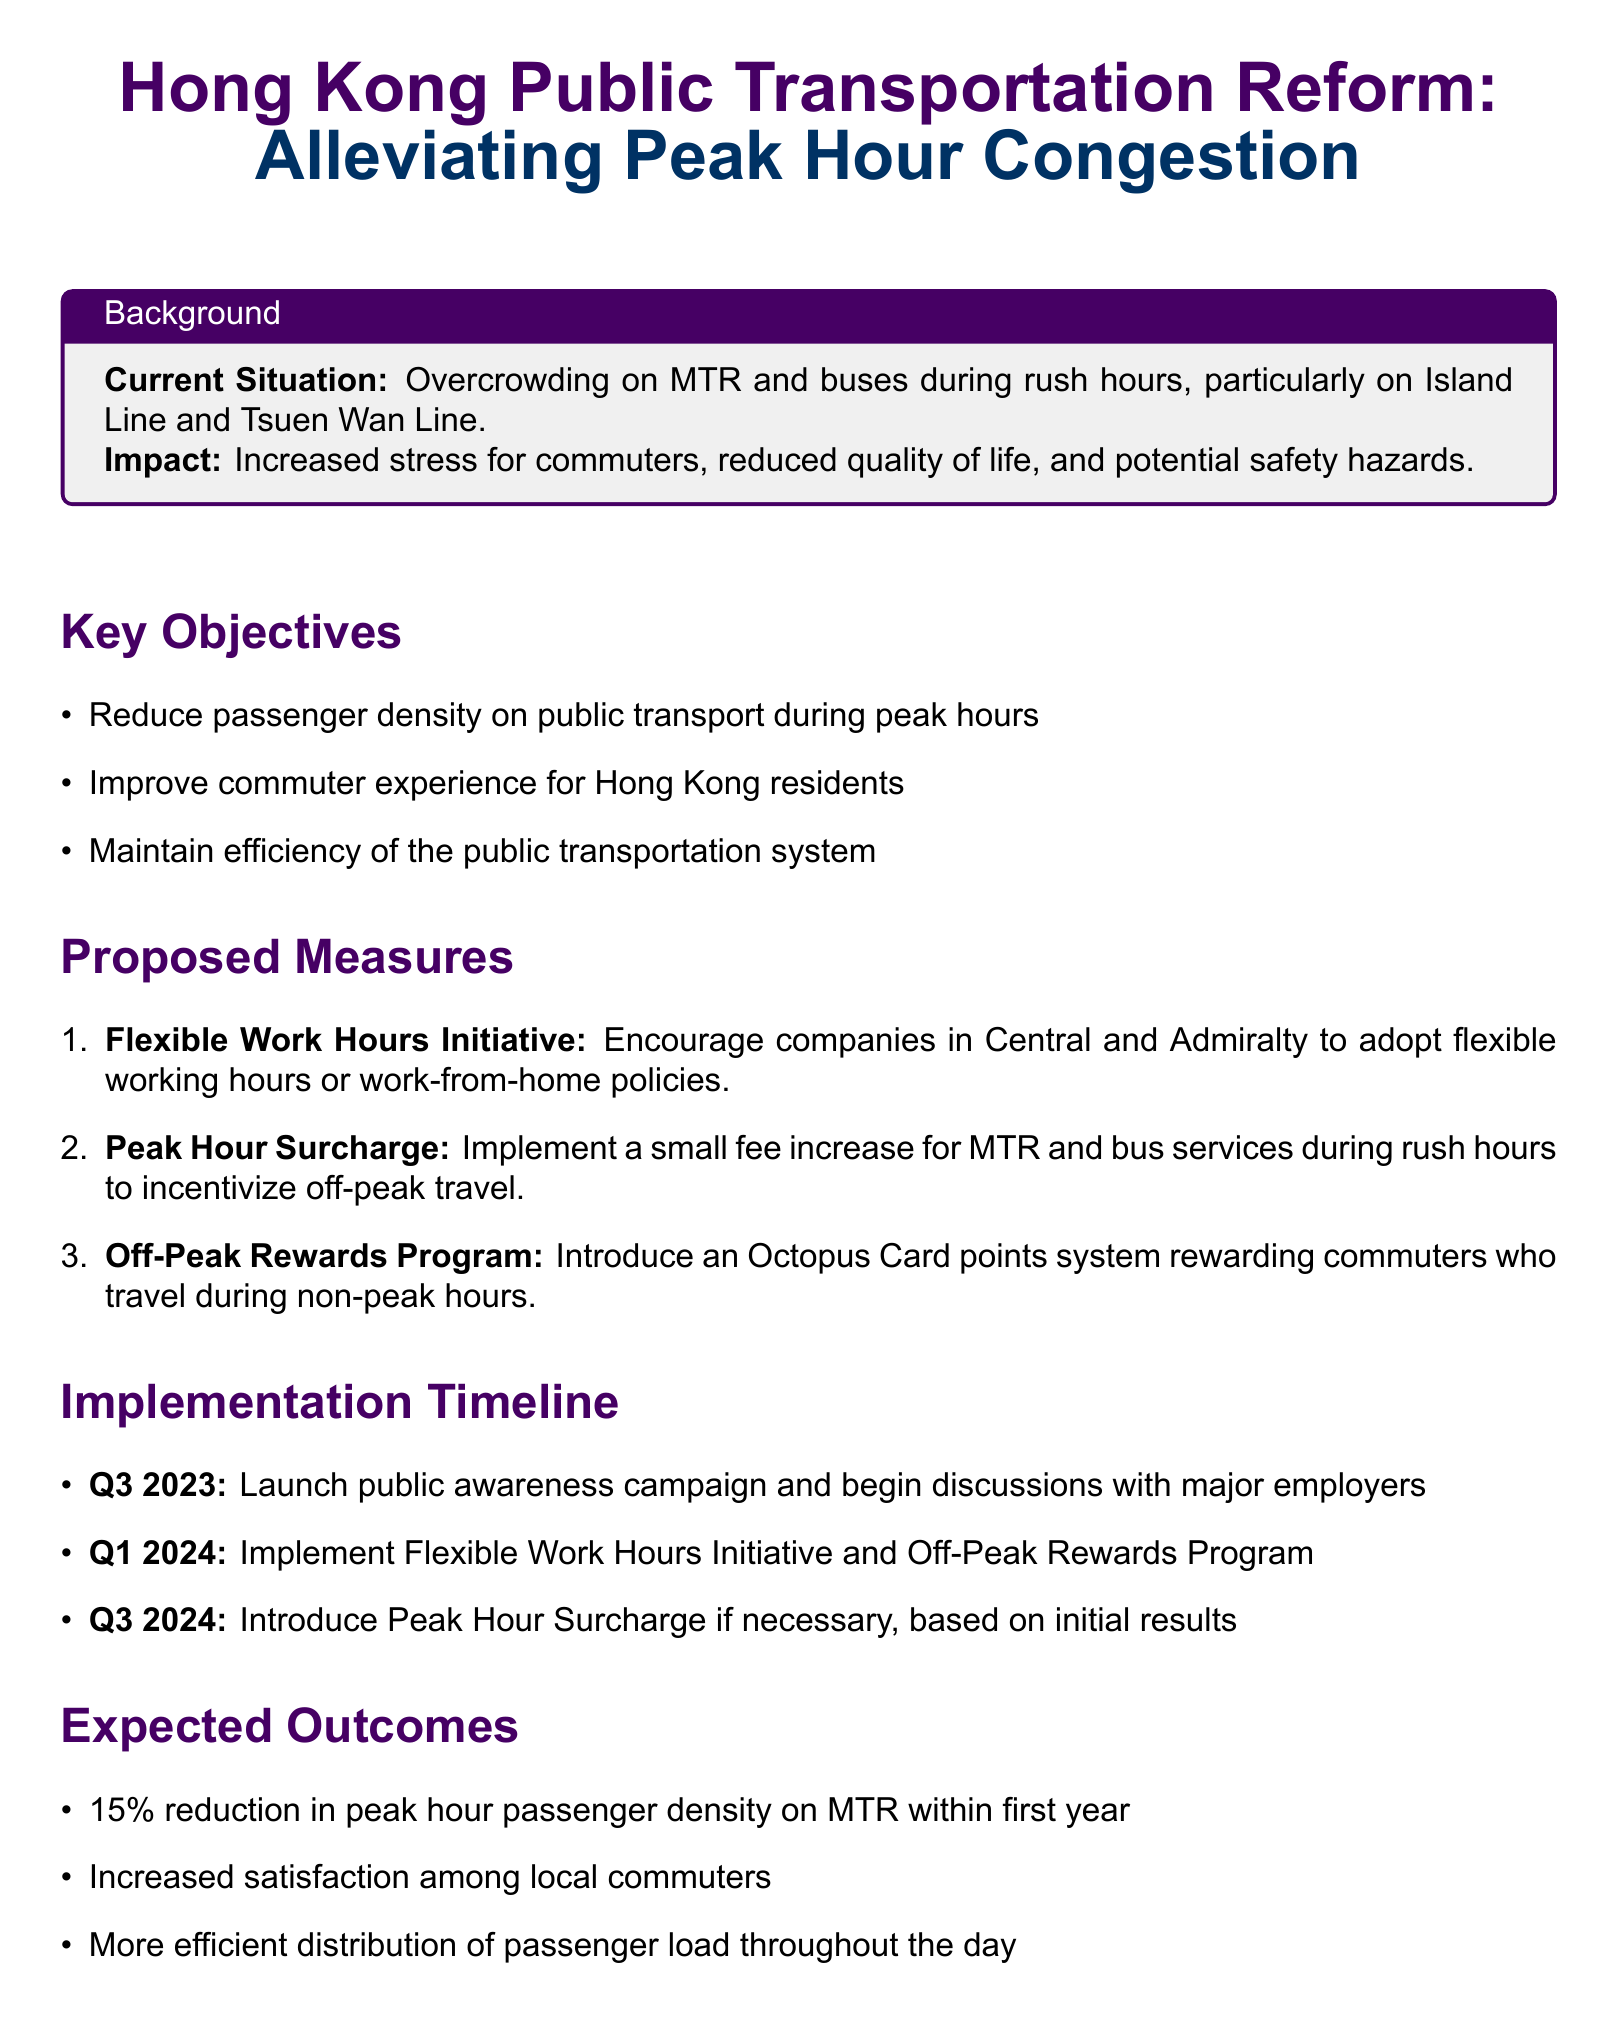What is the main goal of the public transportation reform? The main goal is to alleviate peak hour congestion in Hong Kong's public transport system, as stated in the document title.
Answer: Alleviating peak hour congestion What percentage reduction in peak hour passenger density is expected? The document mentions an expected outcome of a 15% reduction in peak hour passenger density on MTR within the first year.
Answer: 15% What initiative is proposed to encourage off-peak travel? The document lists an "Off-Peak Rewards Program" as a proposed measure to incentivize commuters to travel during non-peak hours.
Answer: Off-Peak Rewards Program When will the Flexible Work Hours Initiative be implemented? The timeline specifies that the Flexible Work Hours Initiative will be implemented in Q1 2024.
Answer: Q1 2024 What is the method for monitoring the initiative's outcomes? The monitoring and evaluation section states that quarterly surveys will be conducted by the Transport Department.
Answer: Quarterly surveys What are the expected results regarding commuter satisfaction? The expected outcome mentioned is increased satisfaction among local commuters due to the proposed measures.
Answer: Increased satisfaction What specific area of Hong Kong does the Peak Hour Surcharge target? The surcharge specifically targets MTR and bus services during rush hours.
Answer: MTR and bus services Which lines are primarily affected by overcrowding according to the document? The document specifies that the Island Line and Tsuen Wan Line are the most affected by overcrowding during rush hours.
Answer: Island Line and Tsuen Wan Line 